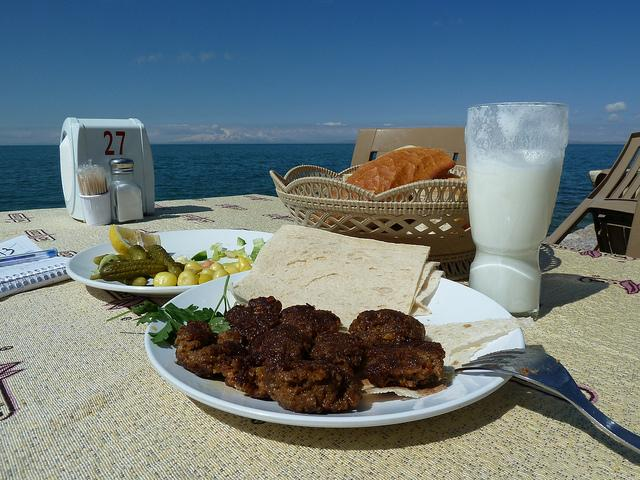Why would someone be seated here? Please explain your reasoning. to eat. The table is set with a full meal, a drink, and a fork. 